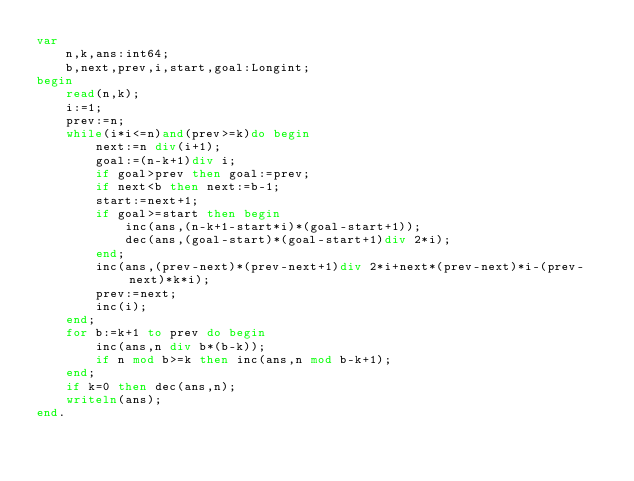Convert code to text. <code><loc_0><loc_0><loc_500><loc_500><_Pascal_>var
	n,k,ans:int64;
	b,next,prev,i,start,goal:Longint;
begin
	read(n,k);
	i:=1;
	prev:=n;
	while(i*i<=n)and(prev>=k)do begin
		next:=n div(i+1);
		goal:=(n-k+1)div i;
		if goal>prev then goal:=prev;
		if next<b then next:=b-1;
		start:=next+1;
		if goal>=start then begin
			inc(ans,(n-k+1-start*i)*(goal-start+1));
			dec(ans,(goal-start)*(goal-start+1)div 2*i);
		end;
		inc(ans,(prev-next)*(prev-next+1)div 2*i+next*(prev-next)*i-(prev-next)*k*i);
		prev:=next;
		inc(i);
	end;
	for b:=k+1 to prev do begin
		inc(ans,n div b*(b-k));
		if n mod b>=k then inc(ans,n mod b-k+1);
	end;
	if k=0 then dec(ans,n);
	writeln(ans);
end.</code> 